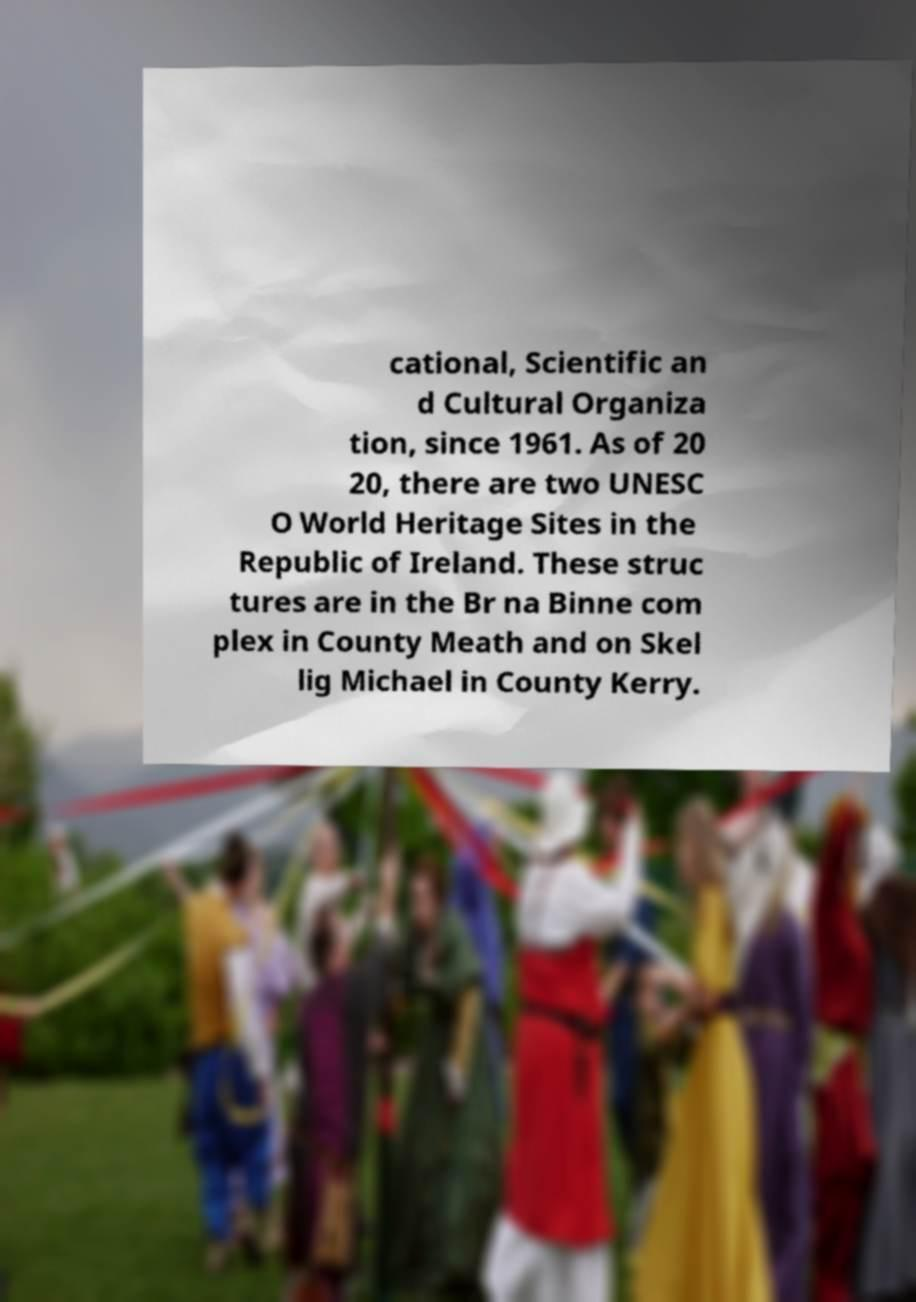There's text embedded in this image that I need extracted. Can you transcribe it verbatim? cational, Scientific an d Cultural Organiza tion, since 1961. As of 20 20, there are two UNESC O World Heritage Sites in the Republic of Ireland. These struc tures are in the Br na Binne com plex in County Meath and on Skel lig Michael in County Kerry. 